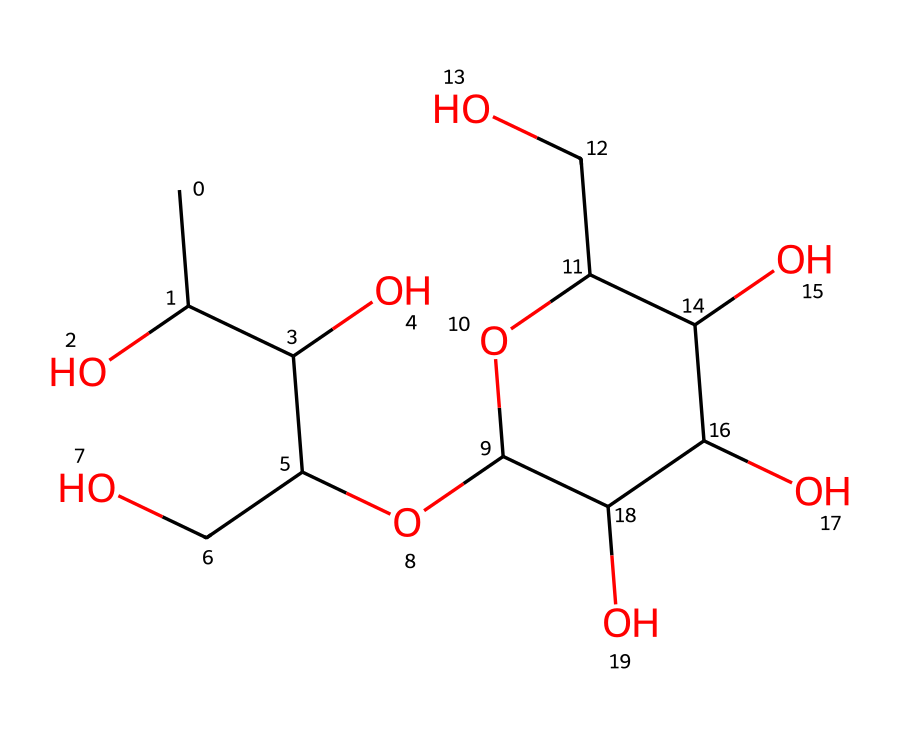What is the main component of aloe vera gel represented here? The chemical depicted in the SMILES structure corresponds to acemannan, which is known as the primary component of aloe vera gel.
Answer: acemannan How many carbon atoms are present in the structure? By analyzing the SMILES representation, we can count the number of carbon atoms (C). There are 9 carbon atoms present in the molecule.
Answer: 9 What type of functional groups are present in this structure? The structure contains multiple hydroxyl groups (-OH) indicating that it has alcohol functional groups, primarily seen due to the presence of several oxygen atoms connected to hydrogen at various points in the formula.
Answer: alcohol What type of glycan is acemannan? Acemannan is a type of polysaccharide or glucan, characterized by its long chain of repeating sugar units indicated in the structure.
Answer: polysaccharide How many hydroxyl groups are in this molecule? Counting the instances of the hydroxyl functional group (-OH) in the structure reveals that there are a total of 5 hydroxyl groups present.
Answer: 5 What is the significance of the ring structure in acemannan? The presence of a ring structure in acemannan contributes to its stability and helps in the hydration properties of aloe vera gel, which plays a key role in its therapeutic and cosmetic properties.
Answer: stability Does acemannan contain any sulfur or nitrogen atoms? Upon reviewing the SMILES representation for this molecule, it is evident that it lacks sulfur and nitrogen atoms altogether.
Answer: no 